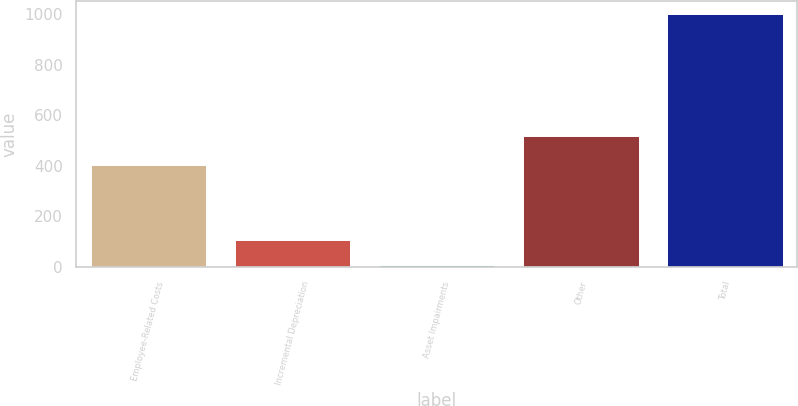Convert chart to OTSL. <chart><loc_0><loc_0><loc_500><loc_500><bar_chart><fcel>Employee-Related Costs<fcel>Incremental Depreciation<fcel>Asset Impairments<fcel>Other<fcel>Total<nl><fcel>404<fcel>106.3<fcel>7<fcel>518<fcel>1000<nl></chart> 